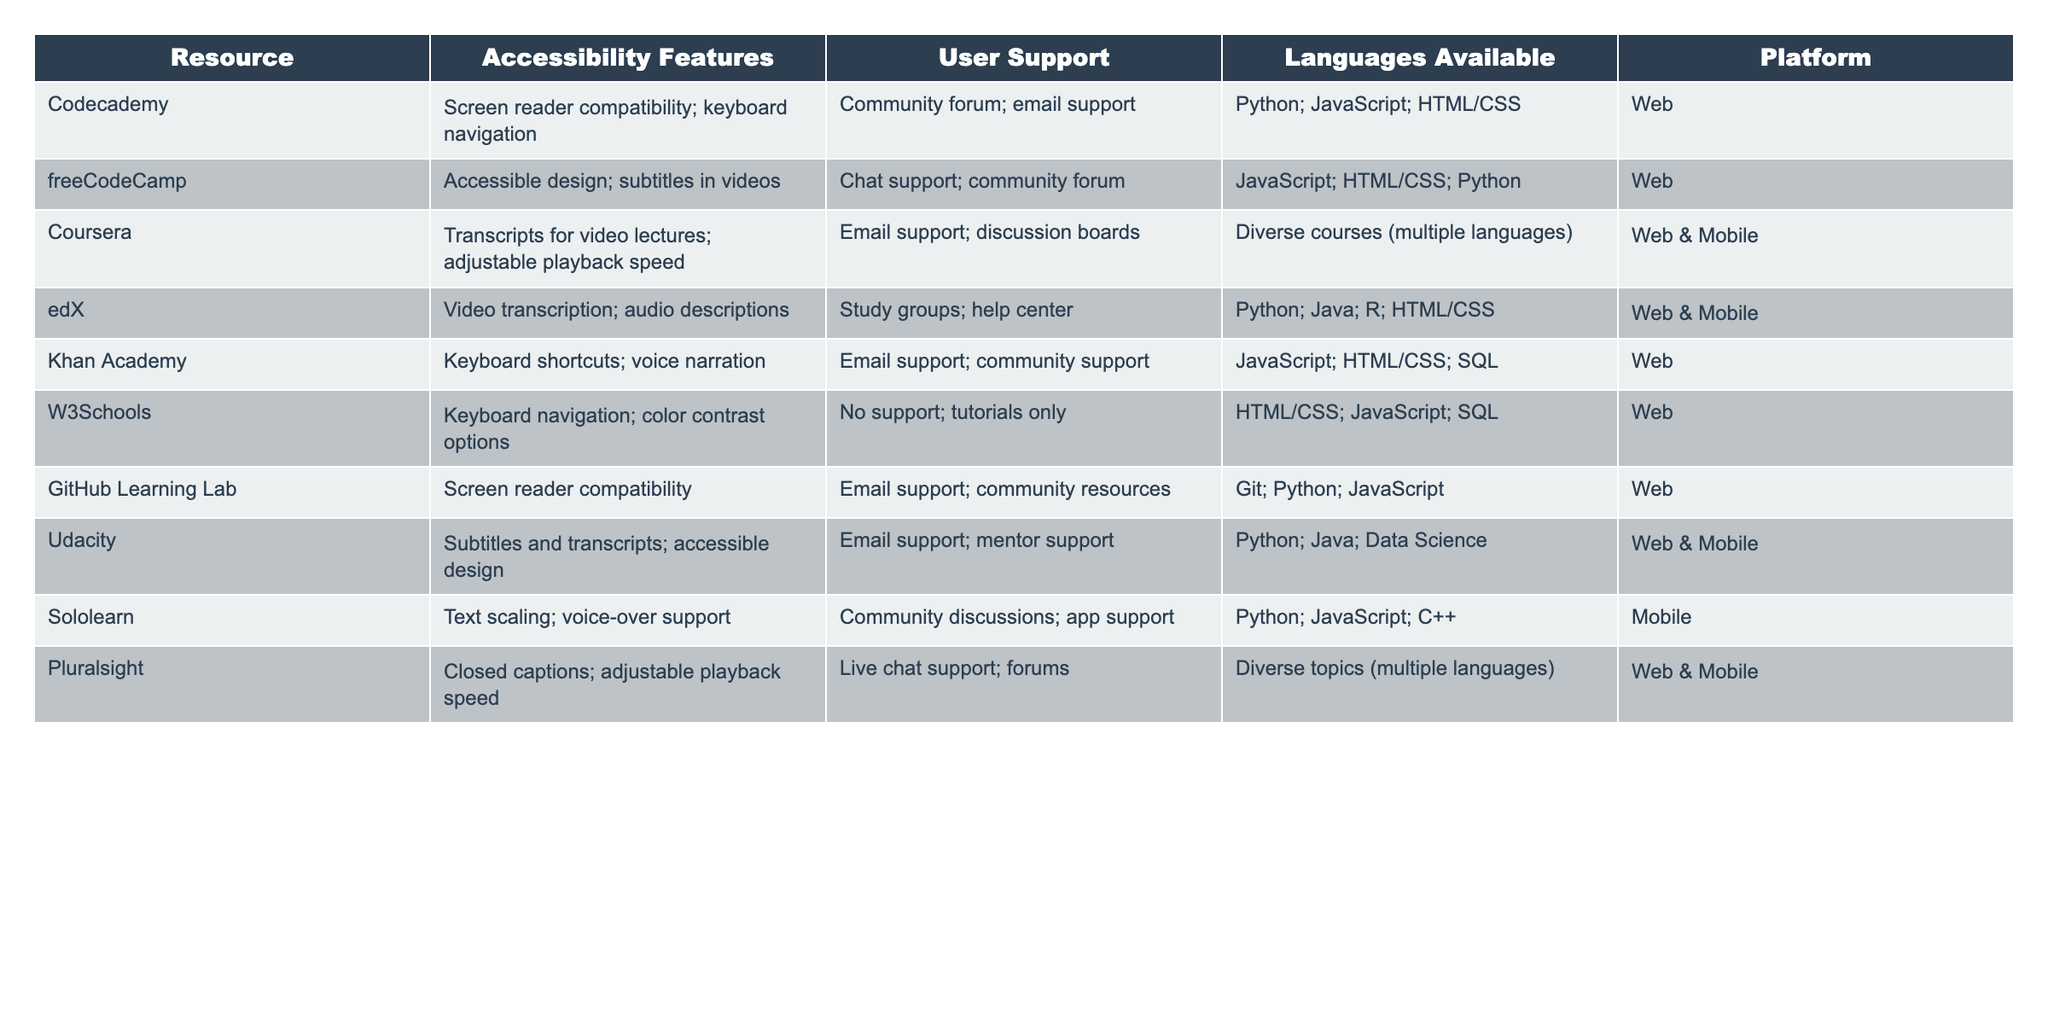What accessibility features does freeCodeCamp offer? The table indicates that freeCodeCamp provides accessible design and subtitles in videos as its accessibility features.
Answer: Accessible design; subtitles in videos How many coding resources support screen reader compatibility? From the table, Codecademy, GitHub Learning Lab, and Udacity all offer screen reader compatibility, totaling three resources.
Answer: 3 Is there a coding resource that provides both chat and email support? The table shows that freeCodeCamp and Udacity provide chat and email support respectively, but no resource offers both at the same time.
Answer: No Which coding resource has the most programming languages available? Coursera offers a diverse range of courses without specifying the exact number of languages, making it difficult to determine the one with the most languages; edX offers Python, Java, R, and HTML/CSS while Udacity focuses on Python, Java, and Data Science. Therefore, multiple resources support diverse languages, but the table does not clarify which has the most.
Answer: Cannot determine What is the total number of platforms across the coding resources listed? The platforms listed are Web, Web & Mobile, and Mobile; counting unique entries shows there are three different platforms.
Answer: 3 Which coding resources offer mobile compatibility? The resources that are available on mobile platforms, according to the table, are Coursera, edX, Udacity, and Sololearn, totaling four resources.
Answer: 4 Do all coding resources provide community support? Upon examining the data, several resources such as W3Schools lack any form of support while others like freeCodeCamp and Khan Academy do offer it. Thus, not all provide community support.
Answer: No What is the difference in the number of languages available between Codecademy and W3Schools? Codecademy offers Python, JavaScript, and HTML/CSS (three languages), while W3Schools offers HTML/CSS, JavaScript, and SQL (three languages) as well. The difference is zero as both provide the same number of languages.
Answer: 0 Which resource offers the least accessibility features? W3Schools lists keyboard navigation and color contrast options, which are fewer compared to other resources.
Answer: W3Schools How many resources provide subtitles or transcripts for their materials? The resources providing subtitles or transcripts include Coursera (transcripts), Udacity (subtitles), and edX (video transcription); this totals three resources.
Answer: 3 